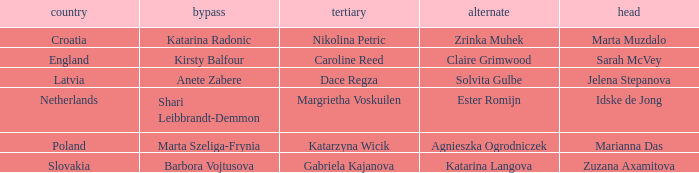Which Lead has Katarina Radonic as Skip? Marta Muzdalo. 